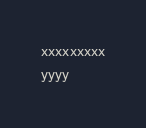<code> <loc_0><loc_0><loc_500><loc_500><_JavaScript_>xxxxxxxxx
yyyy
</code> 